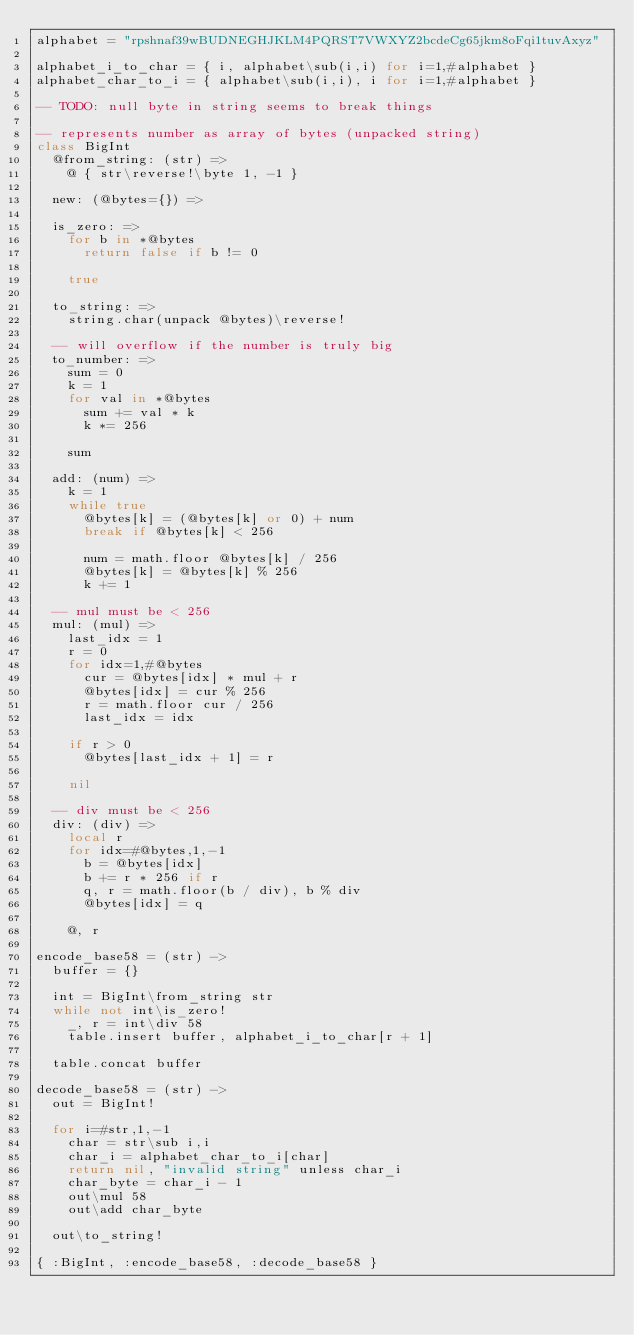<code> <loc_0><loc_0><loc_500><loc_500><_MoonScript_>alphabet = "rpshnaf39wBUDNEGHJKLM4PQRST7VWXYZ2bcdeCg65jkm8oFqi1tuvAxyz"

alphabet_i_to_char = { i, alphabet\sub(i,i) for i=1,#alphabet }
alphabet_char_to_i = { alphabet\sub(i,i), i for i=1,#alphabet }

-- TODO: null byte in string seems to break things

-- represents number as array of bytes (unpacked string)
class BigInt
  @from_string: (str) =>
    @ { str\reverse!\byte 1, -1 }

  new: (@bytes={}) =>

  is_zero: =>
    for b in *@bytes
      return false if b != 0

    true

  to_string: =>
    string.char(unpack @bytes)\reverse!

  -- will overflow if the number is truly big
  to_number: =>
    sum = 0
    k = 1
    for val in *@bytes
      sum += val * k
      k *= 256

    sum

  add: (num) =>
    k = 1
    while true
      @bytes[k] = (@bytes[k] or 0) + num
      break if @bytes[k] < 256

      num = math.floor @bytes[k] / 256
      @bytes[k] = @bytes[k] % 256
      k += 1

  -- mul must be < 256
  mul: (mul) =>
    last_idx = 1
    r = 0
    for idx=1,#@bytes
      cur = @bytes[idx] * mul + r
      @bytes[idx] = cur % 256
      r = math.floor cur / 256
      last_idx = idx

    if r > 0
      @bytes[last_idx + 1] = r

    nil

  -- div must be < 256
  div: (div) =>
    local r
    for idx=#@bytes,1,-1
      b = @bytes[idx]
      b += r * 256 if r
      q, r = math.floor(b / div), b % div
      @bytes[idx] = q

    @, r

encode_base58 = (str) ->
  buffer = {}

  int = BigInt\from_string str
  while not int\is_zero!
    _, r = int\div 58
    table.insert buffer, alphabet_i_to_char[r + 1]

  table.concat buffer

decode_base58 = (str) ->
  out = BigInt!

  for i=#str,1,-1
    char = str\sub i,i
    char_i = alphabet_char_to_i[char]
    return nil, "invalid string" unless char_i
    char_byte = char_i - 1
    out\mul 58
    out\add char_byte

  out\to_string!

{ :BigInt, :encode_base58, :decode_base58 }
</code> 